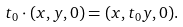<formula> <loc_0><loc_0><loc_500><loc_500>t _ { 0 } \cdot ( x , y , 0 ) = ( x , t _ { 0 } y , 0 ) .</formula> 